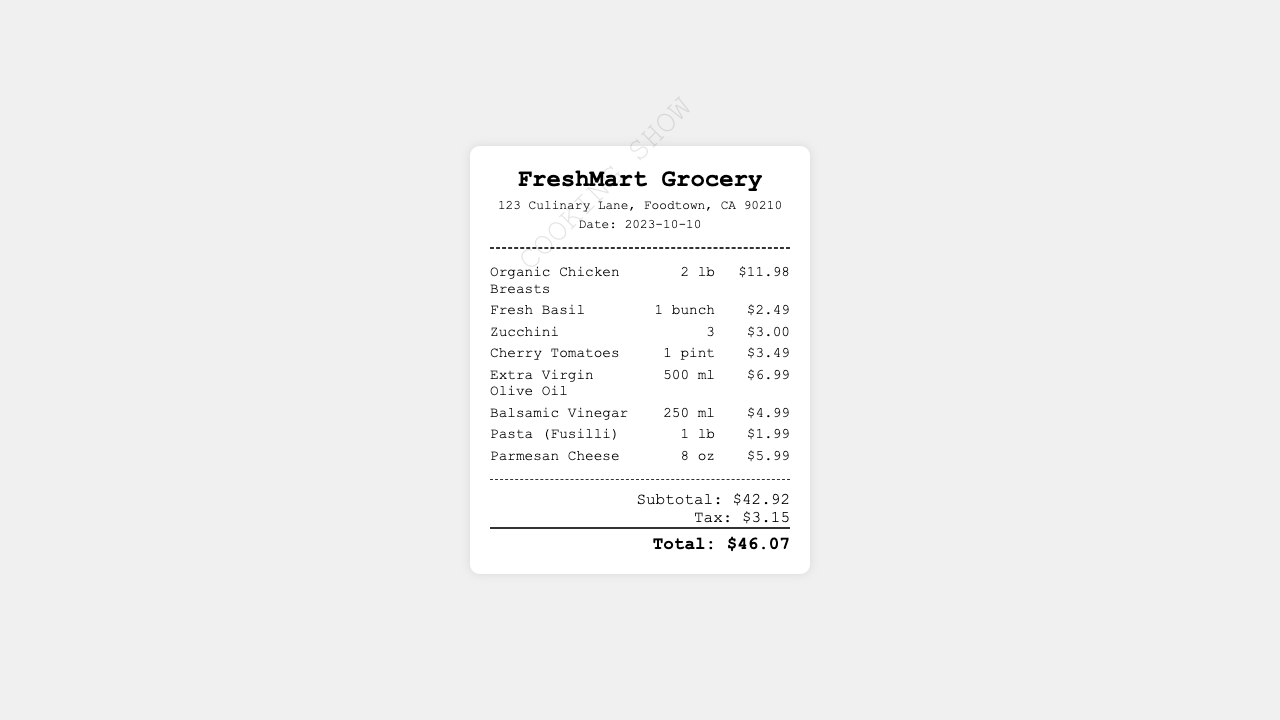What is the store name? The store name is presented clearly at the top of the receipt.
Answer: FreshMart Grocery What items were bought in total? The receipt details the number of individual items purchased.
Answer: 8 What is the date of purchase? The date is specified in the header section of the receipt.
Answer: 2023-10-10 What is the total amount spent? The total amount is mentioned at the bottom of the receipt.
Answer: $46.07 What is the price of Extra Virgin Olive Oil? The price is listed next to the corresponding item on the receipt.
Answer: $6.99 How many pounds of Organic Chicken Breasts were purchased? The quantity is indicated next to the item name on the receipt.
Answer: 2 lb What is the subtotal amount before tax? The subtotal is provided in the totals section of the receipt.
Answer: $42.92 What type of pasta was bought? The type of pasta is specified in its item description.
Answer: Fusilli 